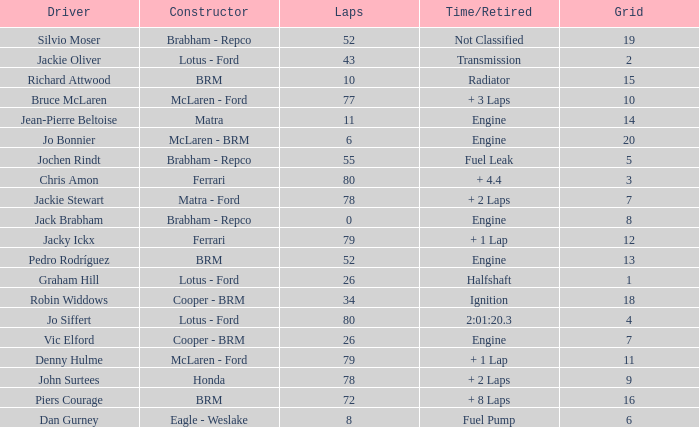When laps are less than 80 and Bruce mclaren is the driver, what is the grid? 10.0. Can you give me this table as a dict? {'header': ['Driver', 'Constructor', 'Laps', 'Time/Retired', 'Grid'], 'rows': [['Silvio Moser', 'Brabham - Repco', '52', 'Not Classified', '19'], ['Jackie Oliver', 'Lotus - Ford', '43', 'Transmission', '2'], ['Richard Attwood', 'BRM', '10', 'Radiator', '15'], ['Bruce McLaren', 'McLaren - Ford', '77', '+ 3 Laps', '10'], ['Jean-Pierre Beltoise', 'Matra', '11', 'Engine', '14'], ['Jo Bonnier', 'McLaren - BRM', '6', 'Engine', '20'], ['Jochen Rindt', 'Brabham - Repco', '55', 'Fuel Leak', '5'], ['Chris Amon', 'Ferrari', '80', '+ 4.4', '3'], ['Jackie Stewart', 'Matra - Ford', '78', '+ 2 Laps', '7'], ['Jack Brabham', 'Brabham - Repco', '0', 'Engine', '8'], ['Jacky Ickx', 'Ferrari', '79', '+ 1 Lap', '12'], ['Pedro Rodríguez', 'BRM', '52', 'Engine', '13'], ['Graham Hill', 'Lotus - Ford', '26', 'Halfshaft', '1'], ['Robin Widdows', 'Cooper - BRM', '34', 'Ignition', '18'], ['Jo Siffert', 'Lotus - Ford', '80', '2:01:20.3', '4'], ['Vic Elford', 'Cooper - BRM', '26', 'Engine', '7'], ['Denny Hulme', 'McLaren - Ford', '79', '+ 1 Lap', '11'], ['John Surtees', 'Honda', '78', '+ 2 Laps', '9'], ['Piers Courage', 'BRM', '72', '+ 8 Laps', '16'], ['Dan Gurney', 'Eagle - Weslake', '8', 'Fuel Pump', '6']]} 